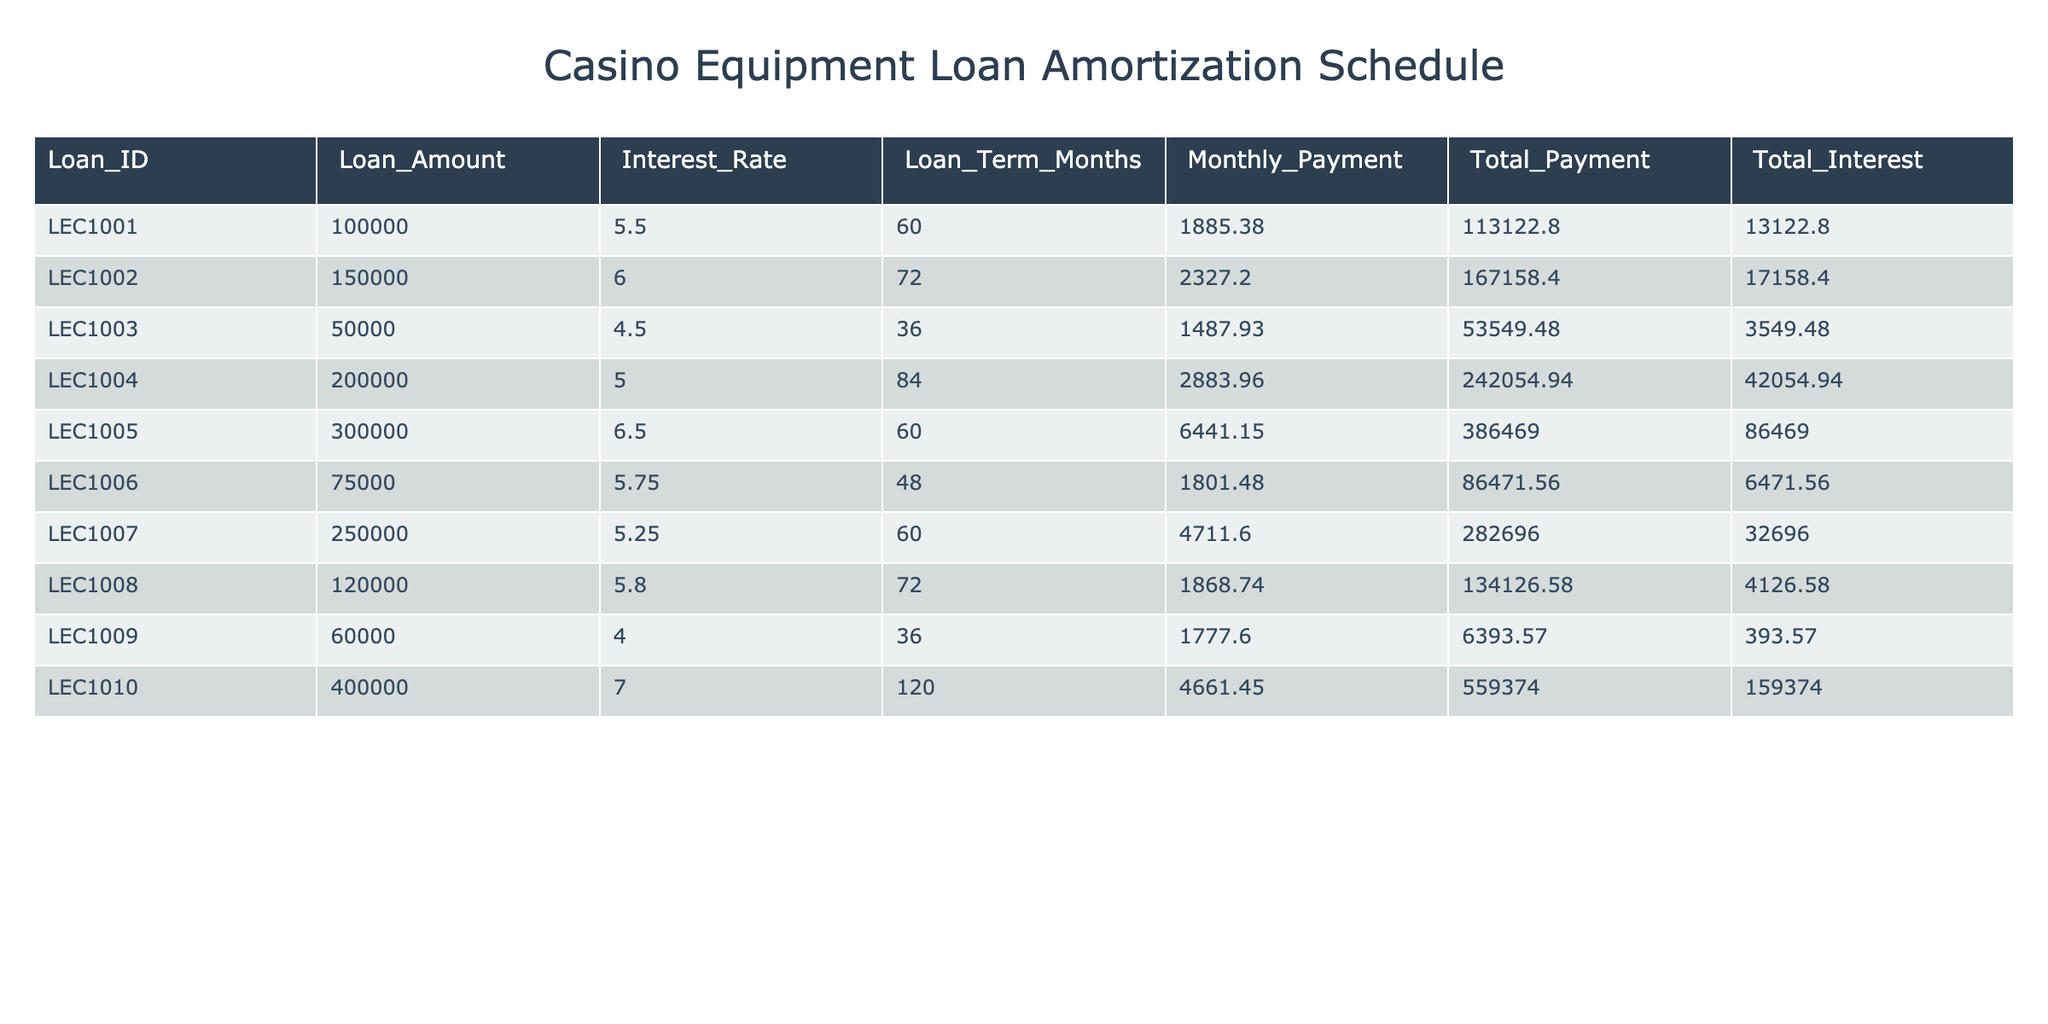What is the loan amount for Loan_ID LEC1003? By looking at the table, I identify the row corresponding to Loan_ID LEC1003, which shows the loan amount of 50,000.
Answer: 50,000 What is the total interest paid for the loan with the highest amount? I examine the loan amounts for each entry, and LEC1010 has the highest loan amount of 400,000. The corresponding total interest is 159,374.
Answer: 159,374 How many months is the loan term for Loan_ID LEC1005? I locate the row for Loan_ID LEC1005 in the table, which indicates a loan term of 60 months.
Answer: 60 Is the monthly payment for Loan_ID LEC1008 greater than 2,000? The monthly payment for Loan_ID LEC1008 is 1,868.74, which is less than 2,000, making the statement false.
Answer: No What is the total payment for the loan with an interest rate of 5.5%? I find the loan corresponding to the interest rate of 5.5%. It is Loan_ID LEC1001, which has a total payment of 113,122.80.
Answer: 113,122.80 What is the average total payment of all loans in the table? First, I sum the total payments for each loan: 113,122.80 + 167,158.40 + 53,549.48 + 242,054.94 + 386,469.00 + 86,471.56 + 282,696.00 + 134,126.58 + 6,393.57 + 559,374.00 = 2,187,025.33. Then, I divide by the total number of loans, which is 10. The average is 2,187,025.33 / 10 = 218,702.53.
Answer: 218,702.53 What is the total interest for LEC1004 and LEC1005 combined? I find the total interest for LEC1004, which is 42,054.94, and for LEC1005, which is 86,469.00. Then, I add these two values together: 42,054.94 + 86,469.00 = 128,523.94.
Answer: 128,523.94 Does any loan have a monthly payment of exactly 4,000? By checking each monthly payment in the table, I confirm that there is no loan with a monthly payment of exactly 4,000.
Answer: No Which loan has the lowest total interest paid? I review the total interest column and find that Loan_ID LEC1009 has the lowest total interest of 393.57 when compared with the others.
Answer: LEC1009 